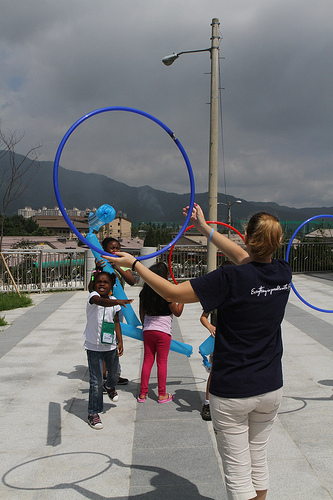<image>
Is the sky above the light pole? Yes. The sky is positioned above the light pole in the vertical space, higher up in the scene. 